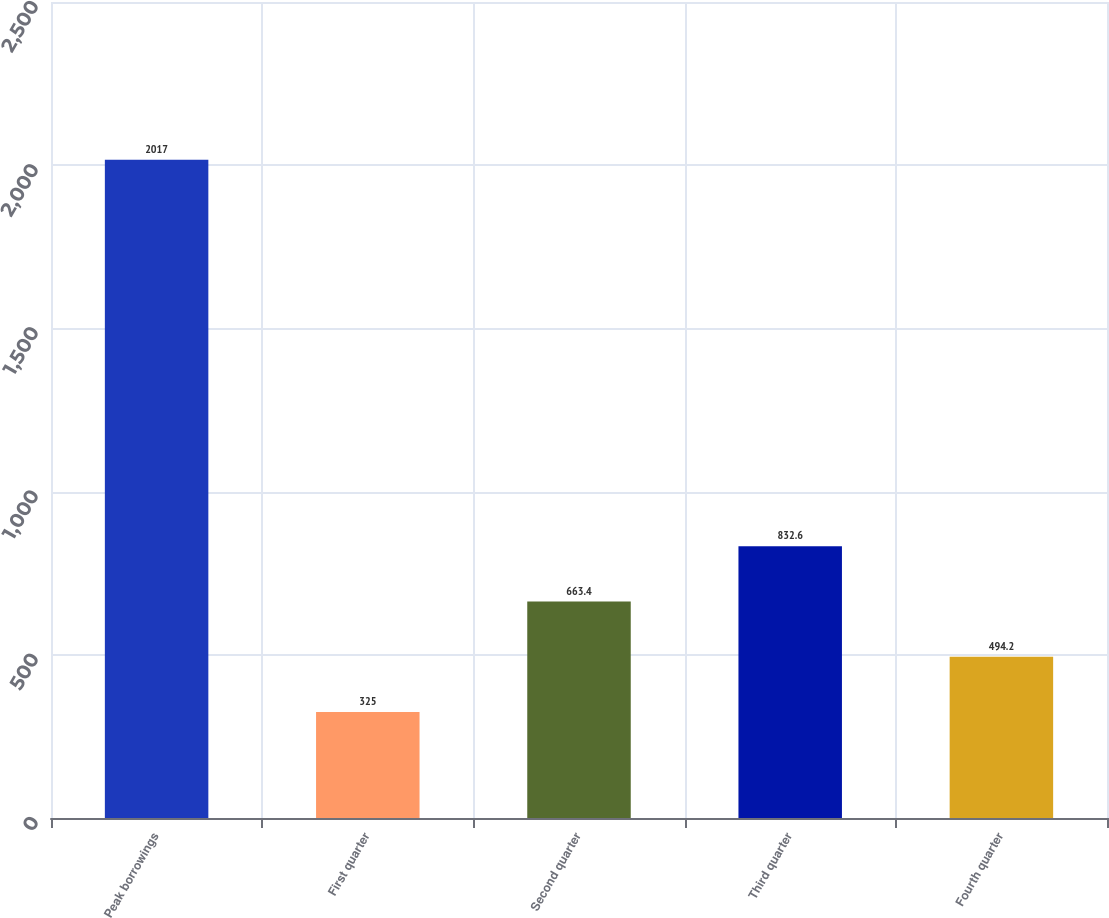Convert chart to OTSL. <chart><loc_0><loc_0><loc_500><loc_500><bar_chart><fcel>Peak borrowings<fcel>First quarter<fcel>Second quarter<fcel>Third quarter<fcel>Fourth quarter<nl><fcel>2017<fcel>325<fcel>663.4<fcel>832.6<fcel>494.2<nl></chart> 